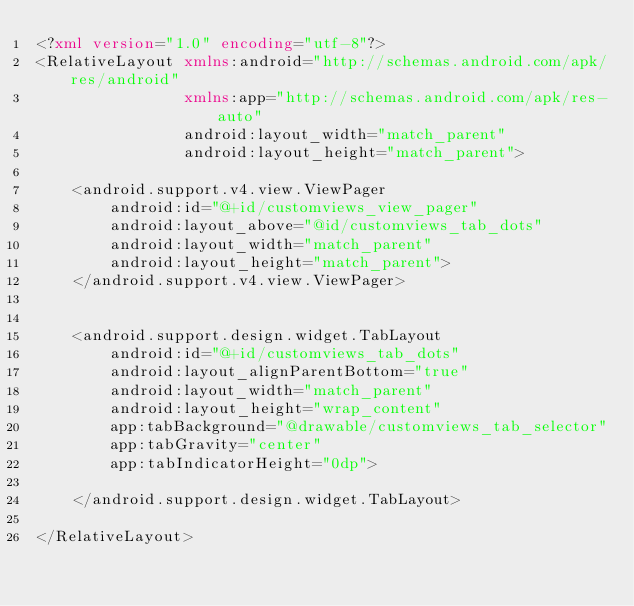<code> <loc_0><loc_0><loc_500><loc_500><_XML_><?xml version="1.0" encoding="utf-8"?>
<RelativeLayout xmlns:android="http://schemas.android.com/apk/res/android"
                xmlns:app="http://schemas.android.com/apk/res-auto"
                android:layout_width="match_parent"
                android:layout_height="match_parent">

    <android.support.v4.view.ViewPager
        android:id="@+id/customviews_view_pager"
        android:layout_above="@id/customviews_tab_dots"
        android:layout_width="match_parent"
        android:layout_height="match_parent">
    </android.support.v4.view.ViewPager>


    <android.support.design.widget.TabLayout
        android:id="@+id/customviews_tab_dots"
        android:layout_alignParentBottom="true"
        android:layout_width="match_parent"
        android:layout_height="wrap_content"
        app:tabBackground="@drawable/customviews_tab_selector"
        app:tabGravity="center"
        app:tabIndicatorHeight="0dp">

    </android.support.design.widget.TabLayout>

</RelativeLayout></code> 